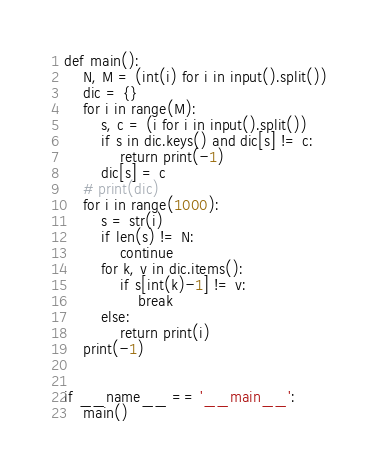Convert code to text. <code><loc_0><loc_0><loc_500><loc_500><_Python_>def main():
    N, M = (int(i) for i in input().split())
    dic = {}
    for i in range(M):
        s, c = (i for i in input().split())
        if s in dic.keys() and dic[s] != c:
            return print(-1)
        dic[s] = c
    # print(dic)
    for i in range(1000):
        s = str(i)
        if len(s) != N:
            continue
        for k, v in dic.items():
            if s[int(k)-1] != v:
                break
        else:
            return print(i)
    print(-1)


if __name__ == '__main__':
    main()
</code> 